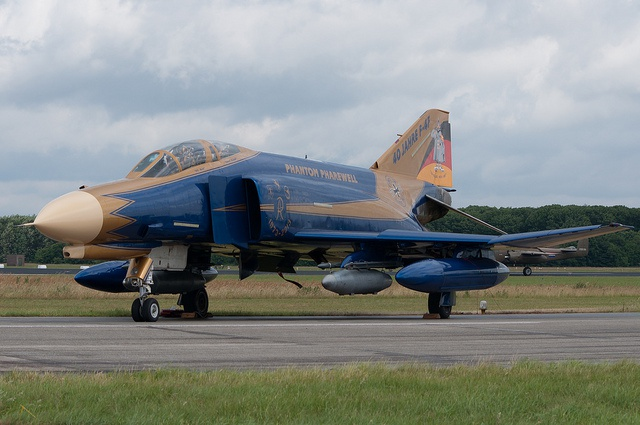Describe the objects in this image and their specific colors. I can see a airplane in lightgray, black, gray, and navy tones in this image. 